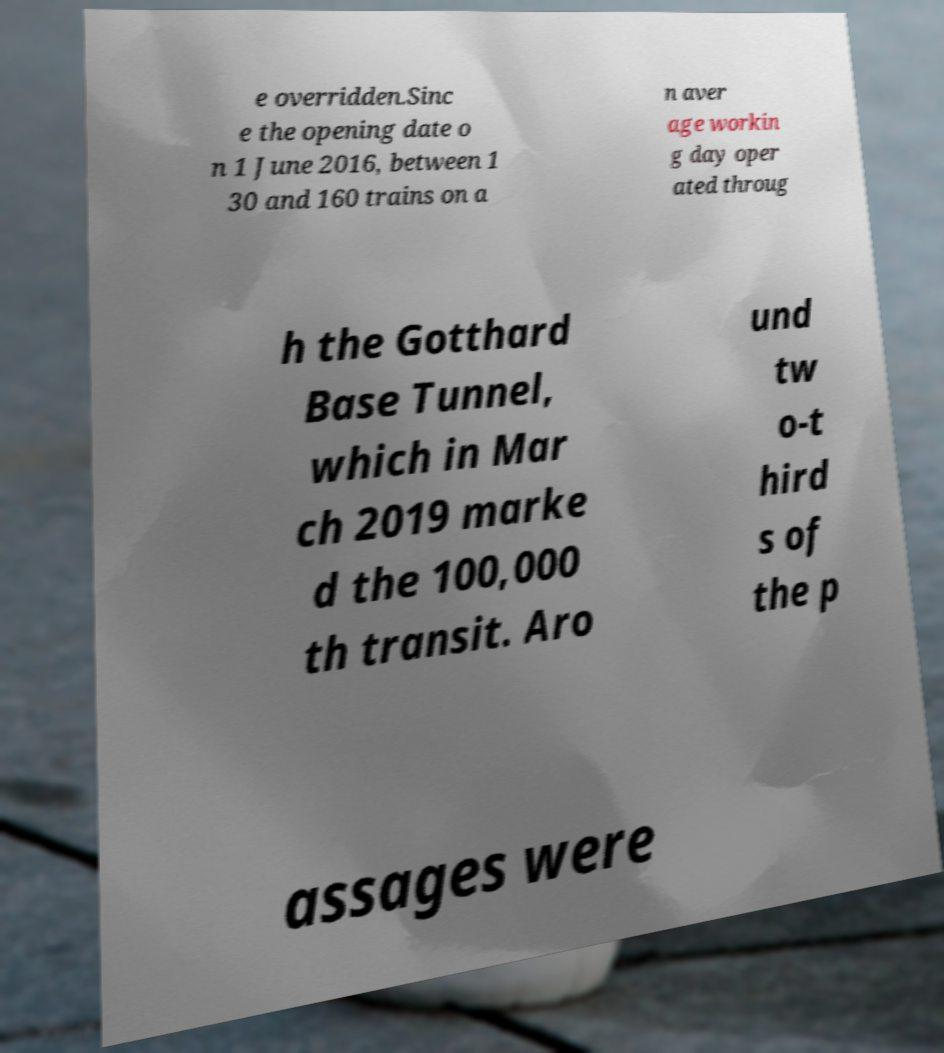Please read and relay the text visible in this image. What does it say? e overridden.Sinc e the opening date o n 1 June 2016, between 1 30 and 160 trains on a n aver age workin g day oper ated throug h the Gotthard Base Tunnel, which in Mar ch 2019 marke d the 100,000 th transit. Aro und tw o-t hird s of the p assages were 